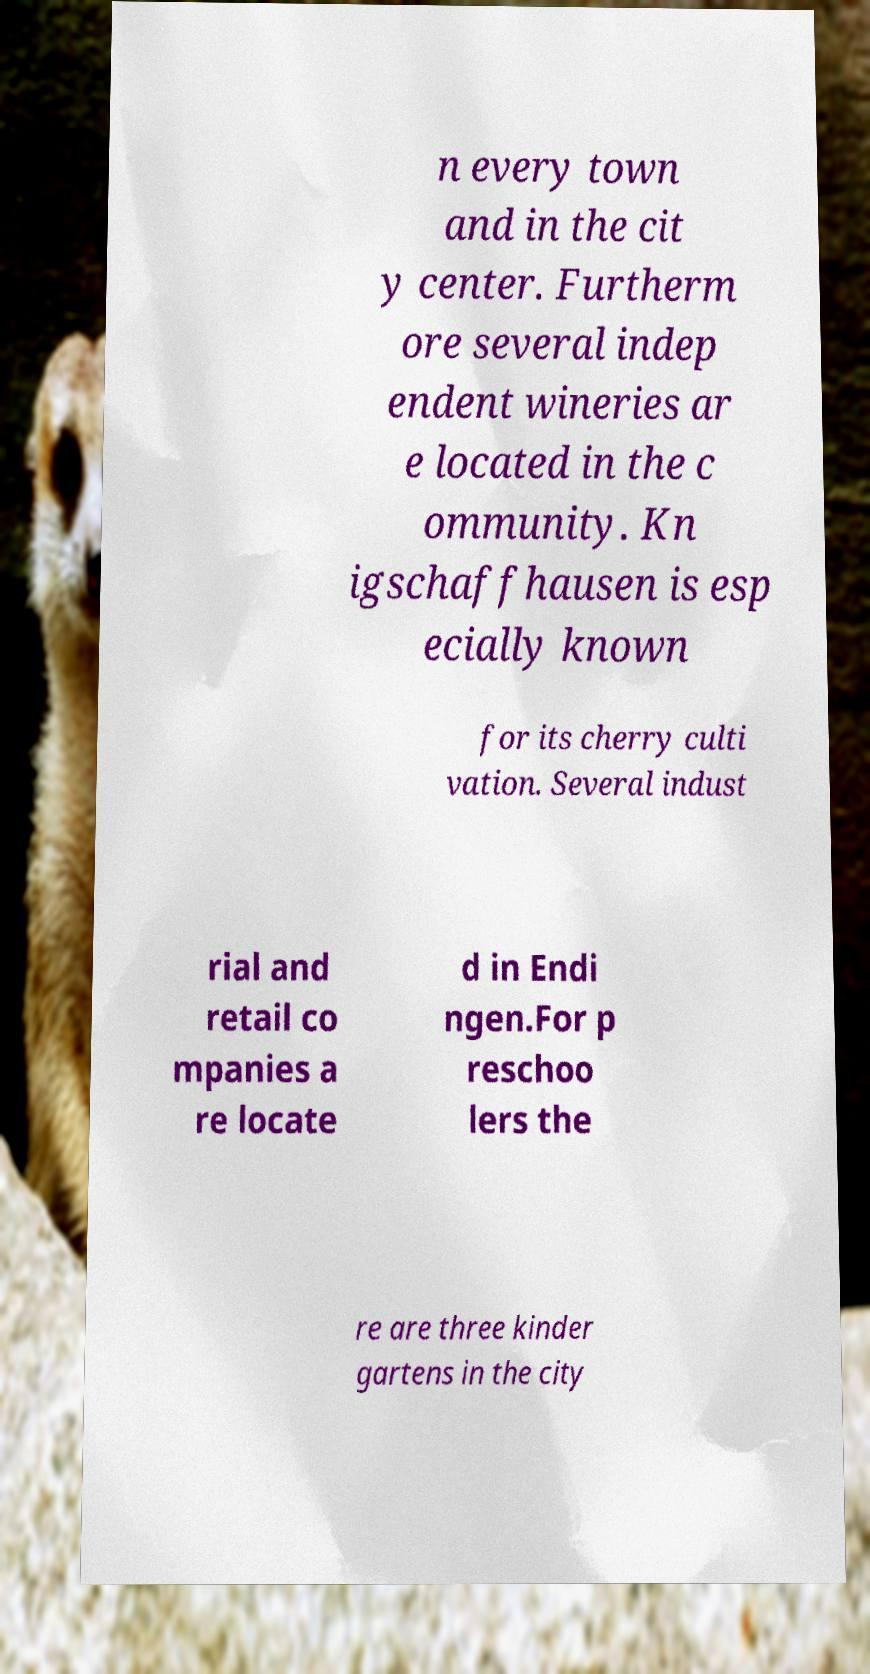Could you extract and type out the text from this image? n every town and in the cit y center. Furtherm ore several indep endent wineries ar e located in the c ommunity. Kn igschaffhausen is esp ecially known for its cherry culti vation. Several indust rial and retail co mpanies a re locate d in Endi ngen.For p reschoo lers the re are three kinder gartens in the city 